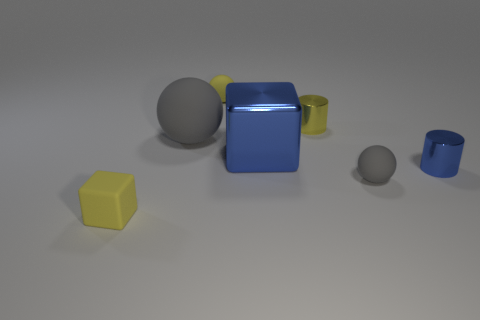Are the cube on the right side of the yellow cube and the cube on the left side of the yellow sphere made of the same material?
Provide a succinct answer. No. There is a cylinder in front of the cylinder behind the blue shiny thing that is in front of the blue metallic cube; how big is it?
Keep it short and to the point. Small. What is the material of the yellow cube that is the same size as the yellow cylinder?
Your answer should be compact. Rubber. Is there a yellow thing of the same size as the yellow matte ball?
Your response must be concise. Yes. Is the small gray object the same shape as the big gray matte thing?
Give a very brief answer. Yes. Is there a small blue shiny thing behind the cylinder in front of the cube behind the small gray ball?
Offer a terse response. No. What number of other things are there of the same color as the large matte ball?
Offer a very short reply. 1. Do the rubber object that is behind the large matte sphere and the yellow cube that is in front of the yellow shiny thing have the same size?
Your answer should be very brief. Yes. Is the number of shiny objects that are in front of the big blue block the same as the number of yellow metal cylinders that are on the right side of the tiny gray matte object?
Ensure brevity in your answer.  No. Is there any other thing that has the same material as the large blue object?
Offer a very short reply. Yes. 